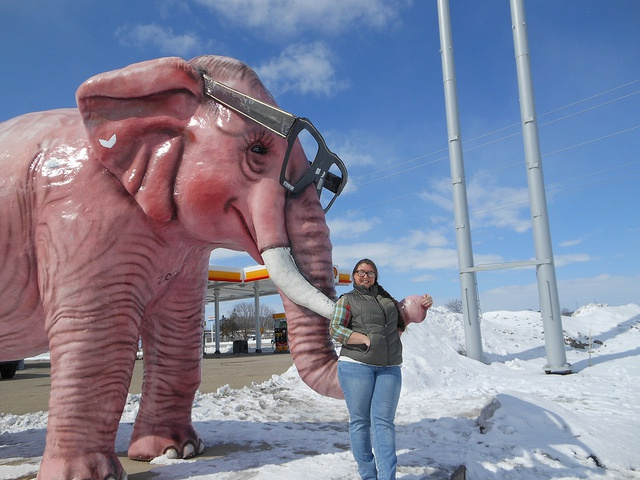Describe the objects in this image and their specific colors. I can see elephant in gray, brown, darkgray, and maroon tones and people in gray and black tones in this image. 